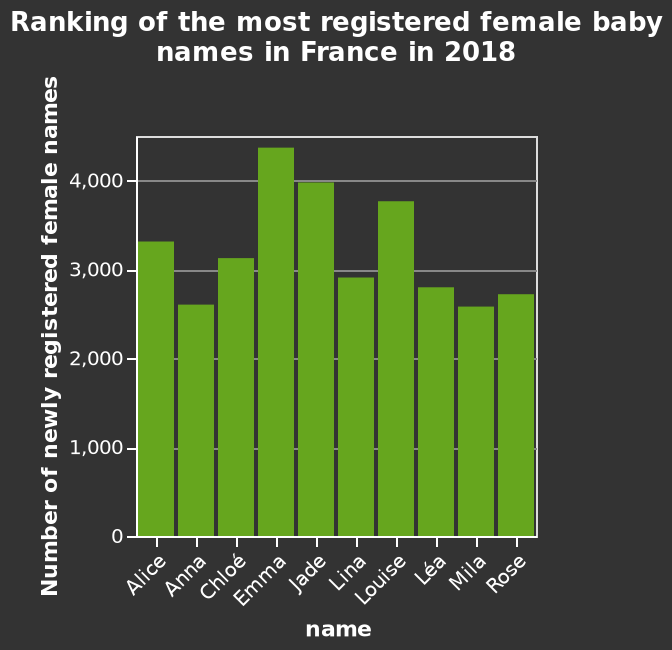<image>
What information does the bar diagram provide? The bar diagram provides information about the number of newly registered female names in France in 2018, based on their ranking. 